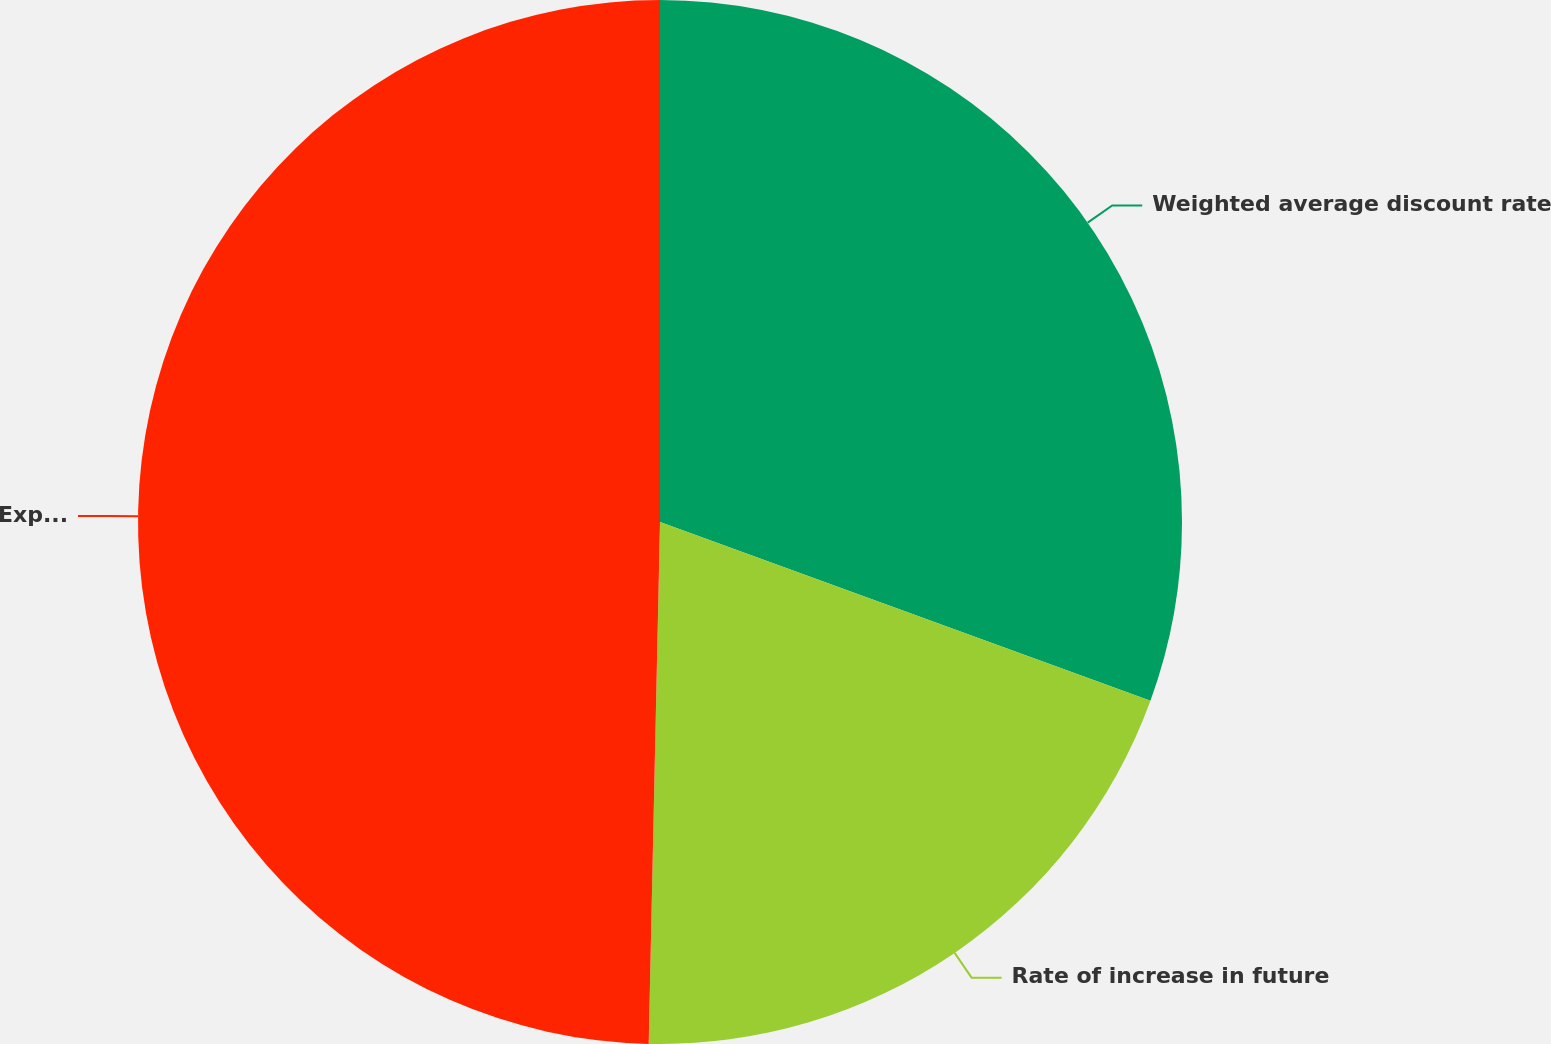Convert chart. <chart><loc_0><loc_0><loc_500><loc_500><pie_chart><fcel>Weighted average discount rate<fcel>Rate of increase in future<fcel>Expected long-term rate of<nl><fcel>30.56%<fcel>19.78%<fcel>49.65%<nl></chart> 